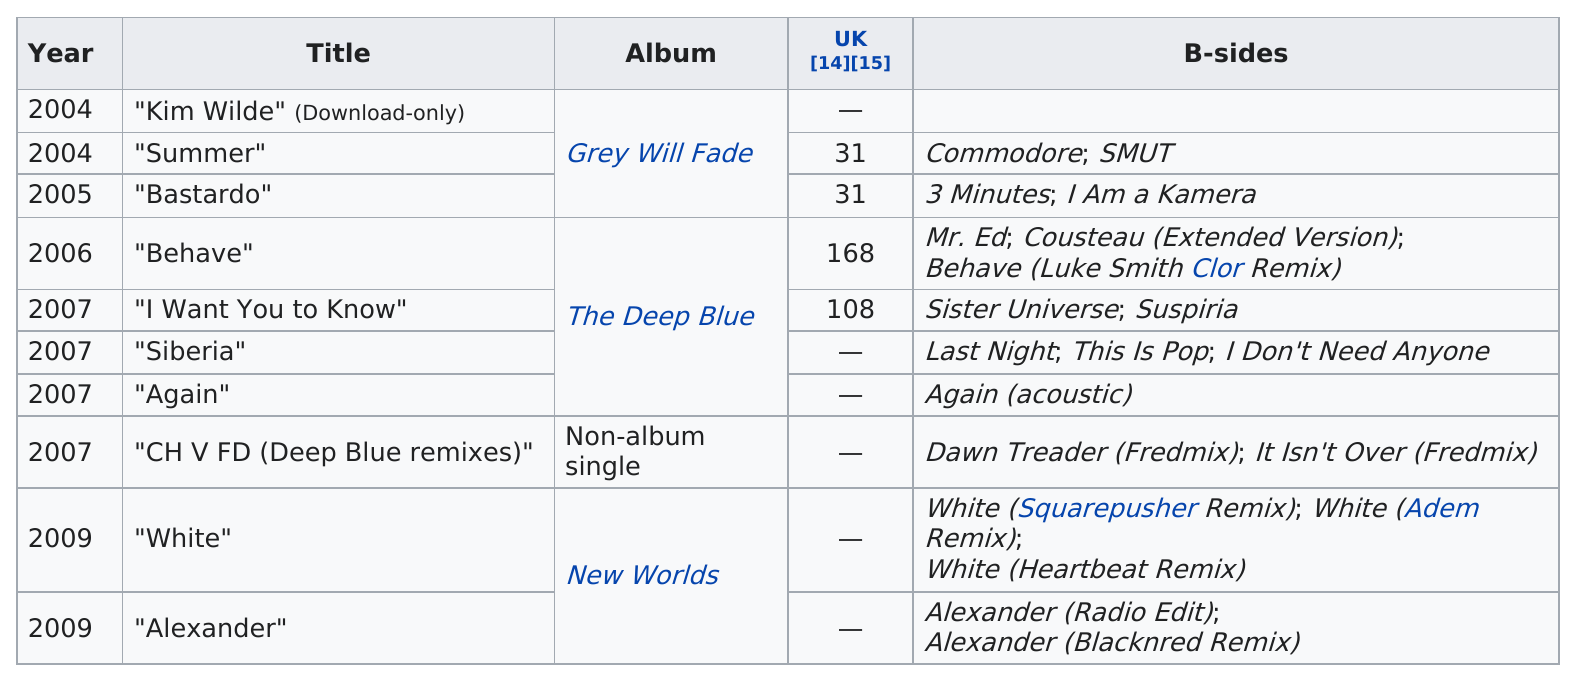Draw attention to some important aspects in this diagram. Out of the titles, how many are more than one word long? The single "Behave" was the only one released in 2006. The b-side on the only non-album single is "Dawn Treader (Fredmix)" and "It Isn't Over (Fredmix). The title "CH V FD (Deep Blue remixes)" did not have an associated album. There were 4 titles in 2007. 